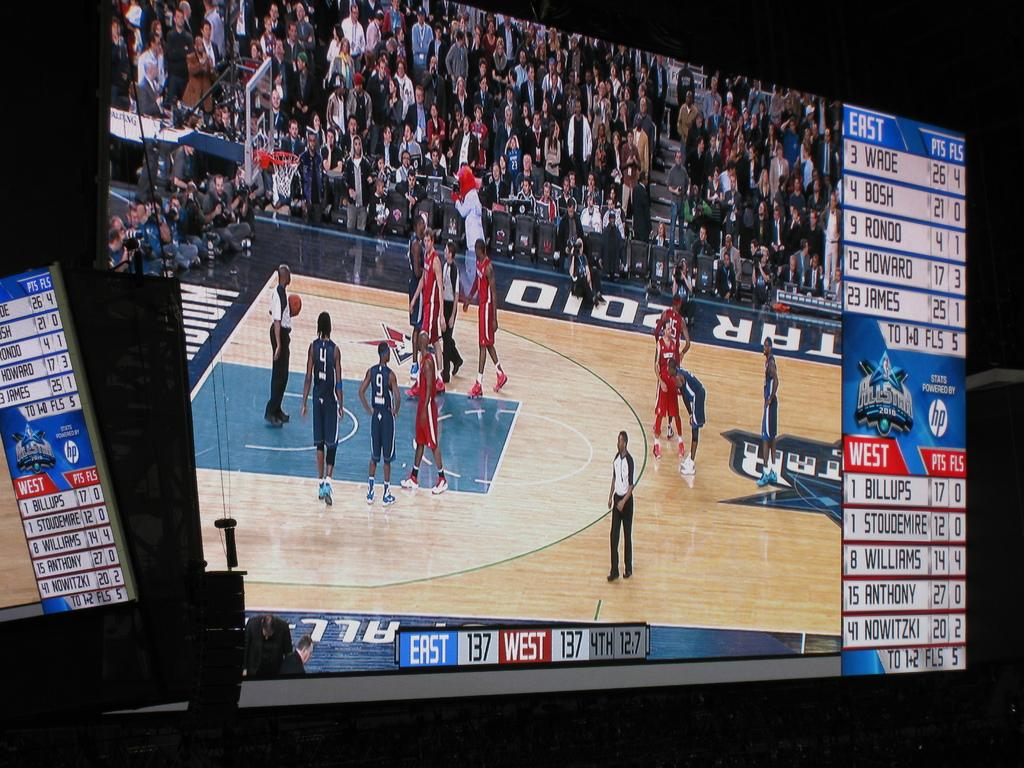<image>
Render a clear and concise summary of the photo. tv showing the nba all star game with the east and west teams tied at 137 in the 4th 